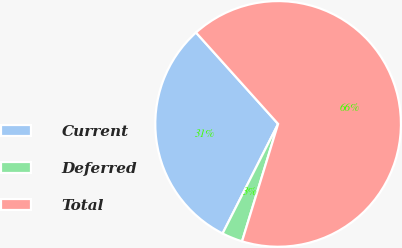Convert chart. <chart><loc_0><loc_0><loc_500><loc_500><pie_chart><fcel>Current<fcel>Deferred<fcel>Total<nl><fcel>30.88%<fcel>2.72%<fcel>66.39%<nl></chart> 